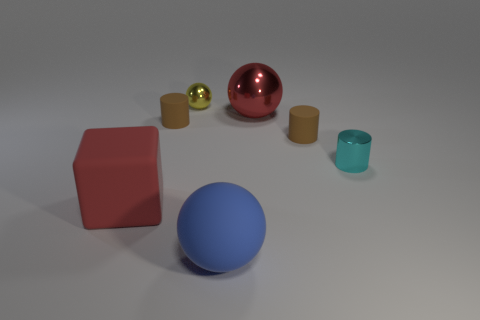Do the large red matte thing and the blue matte thing have the same shape?
Your answer should be compact. No. Are there any red metallic objects in front of the big rubber object in front of the red thing that is on the left side of the tiny yellow sphere?
Ensure brevity in your answer.  No. What number of other objects are there of the same color as the block?
Keep it short and to the point. 1. Does the brown matte object that is on the right side of the blue object have the same size as the red object to the left of the big red sphere?
Keep it short and to the point. No. Are there the same number of small brown rubber objects left of the large blue matte ball and big metallic spheres that are in front of the cyan cylinder?
Your response must be concise. No. Is there anything else that is the same material as the red sphere?
Your response must be concise. Yes. There is a red rubber thing; is it the same size as the red thing that is behind the big cube?
Keep it short and to the point. Yes. What is the large sphere in front of the small shiny thing that is right of the large shiny sphere made of?
Your response must be concise. Rubber. Are there the same number of yellow things that are on the right side of the big red shiny object and rubber things?
Provide a short and direct response. No. There is a ball that is both to the left of the big metallic ball and behind the large blue rubber ball; what is its size?
Your response must be concise. Small. 